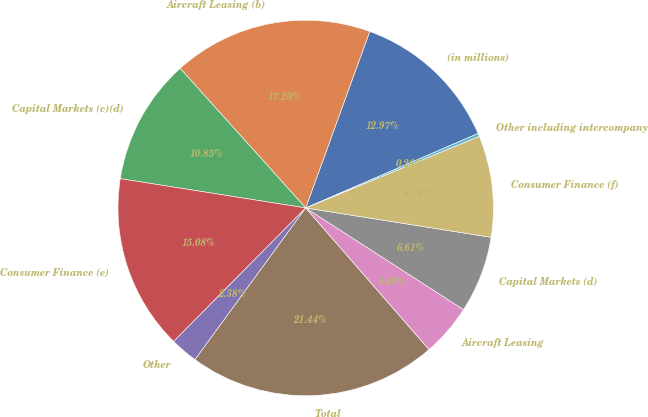Convert chart. <chart><loc_0><loc_0><loc_500><loc_500><pie_chart><fcel>(in millions)<fcel>Aircraft Leasing (b)<fcel>Capital Markets (c)(d)<fcel>Consumer Finance (e)<fcel>Other<fcel>Total<fcel>Aircraft Leasing<fcel>Capital Markets (d)<fcel>Consumer Finance (f)<fcel>Other including intercompany<nl><fcel>12.97%<fcel>17.2%<fcel>10.85%<fcel>15.08%<fcel>2.38%<fcel>21.44%<fcel>4.49%<fcel>6.61%<fcel>8.73%<fcel>0.26%<nl></chart> 